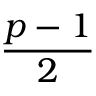<formula> <loc_0><loc_0><loc_500><loc_500>\frac { p - 1 } { 2 }</formula> 